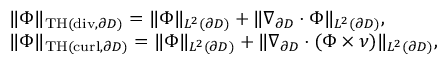Convert formula to latex. <formula><loc_0><loc_0><loc_500><loc_500>\begin{array} { r l } & { \| { \Phi } \| _ { T H ( d i v , \partial D ) } = \| { \Phi } \| _ { L ^ { 2 } ( \partial D ) } + \| \nabla _ { \partial D } \cdot { \Phi } \| _ { L ^ { 2 } ( \partial D ) } , } \\ & { \| { \Phi } \| _ { T H ( c u r l , \partial D ) } = \| { \Phi } \| _ { L ^ { 2 } ( \partial D ) } + \| \nabla _ { \partial D } \cdot ( { \Phi } \times \nu ) \| _ { L ^ { 2 } ( \partial D ) } , } \end{array}</formula> 